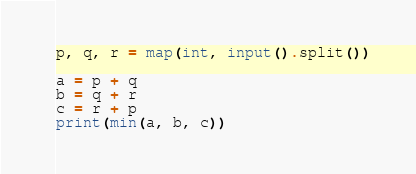<code> <loc_0><loc_0><loc_500><loc_500><_Python_>p, q, r = map(int, input().split())

a = p + q
b = q + r
c = r + p
print(min(a, b, c))</code> 